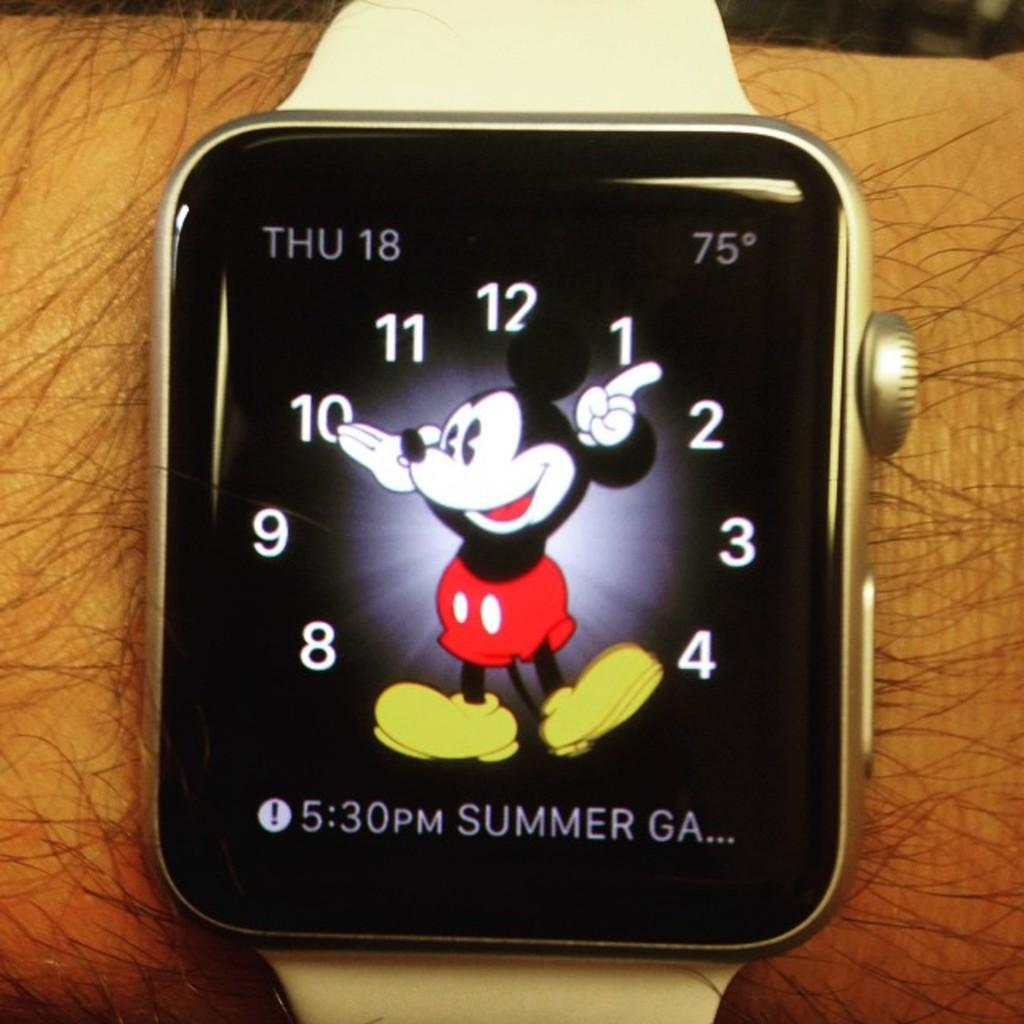<image>
Provide a brief description of the given image. A smart watch with mickey as the hands with the date being thu 18 on the top left. 